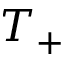Convert formula to latex. <formula><loc_0><loc_0><loc_500><loc_500>T _ { + }</formula> 